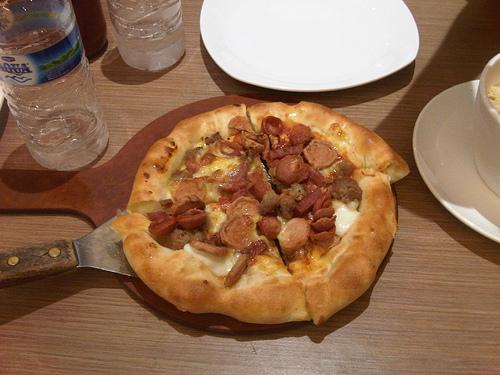Is this a full size pizza?
Write a very short answer. No. Does the pizza have a thin crust?
Keep it brief. No. What did the person use to bring the pizza to the table?
Keep it brief. Pizza board. 